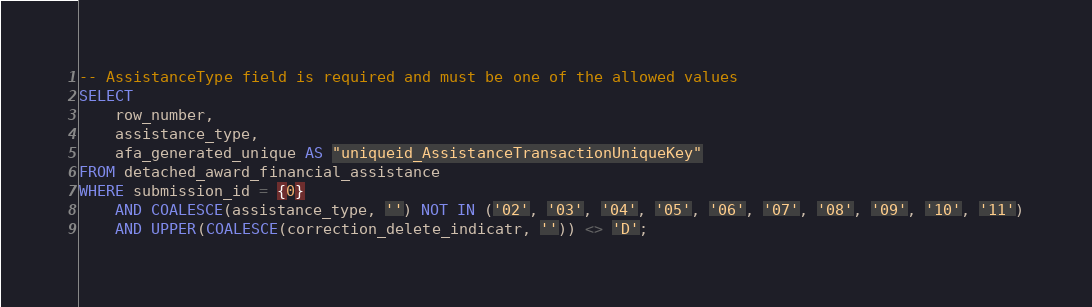Convert code to text. <code><loc_0><loc_0><loc_500><loc_500><_SQL_>-- AssistanceType field is required and must be one of the allowed values
SELECT
    row_number,
    assistance_type,
    afa_generated_unique AS "uniqueid_AssistanceTransactionUniqueKey"
FROM detached_award_financial_assistance
WHERE submission_id = {0}
    AND COALESCE(assistance_type, '') NOT IN ('02', '03', '04', '05', '06', '07', '08', '09', '10', '11')
    AND UPPER(COALESCE(correction_delete_indicatr, '')) <> 'D';
</code> 